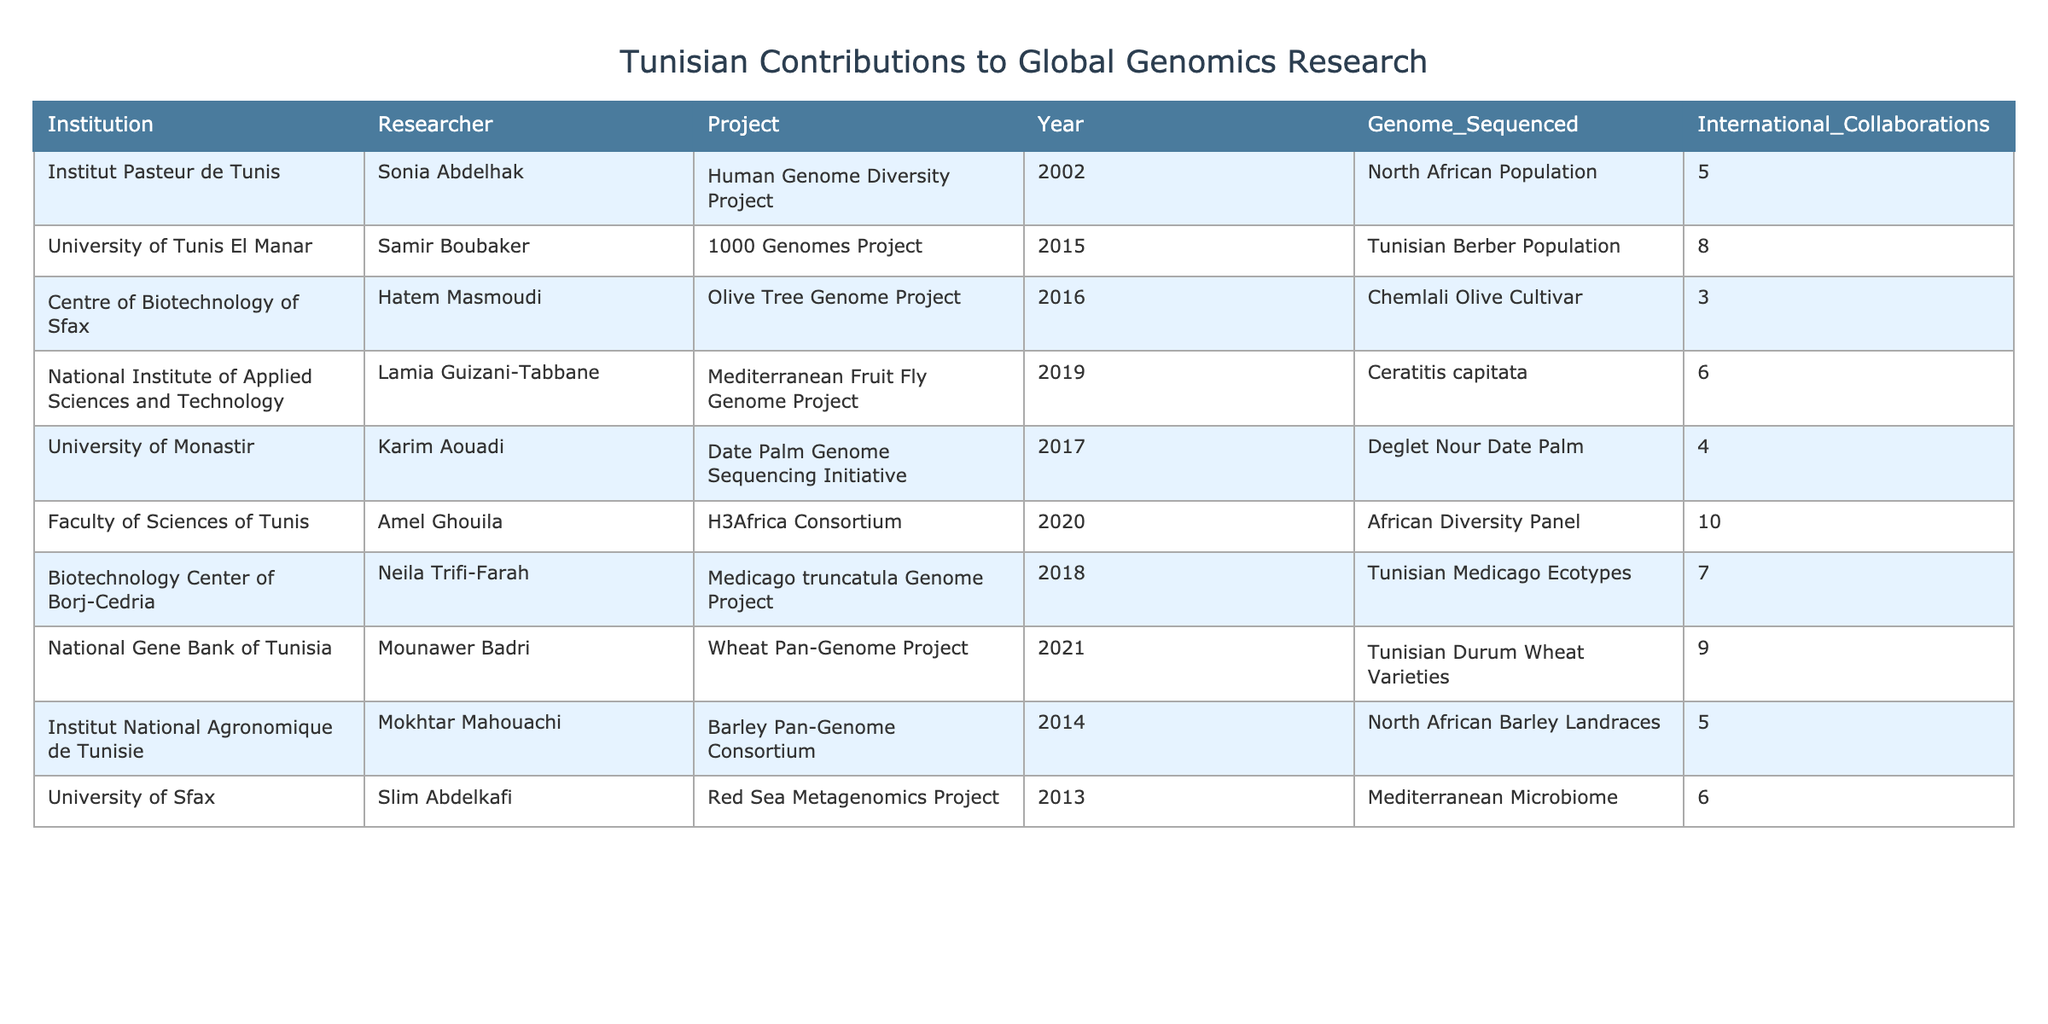What institution contributed to the H3Africa Consortium project? In the table, the project "H3Africa Consortium" is associated with "Faculty of Sciences of Tunis."
Answer: Faculty of Sciences of Tunis How many genomes were sequenced by the National Gene Bank of Tunisia? The "Wheat Pan-Genome Project" at the National Gene Bank of Tunisia sequenced "Tunisian Durum Wheat Varieties," which is indicated to have sequenced 9 genomes.
Answer: 9 Who was involved in the Olive Tree Genome Project? The table shows that Hatem Masmoudi from the Centre of Biotechnology of Sfax was involved in the Olive Tree Genome Project.
Answer: Hatem Masmoudi What was the largest number of genomes sequenced in a single project? By looking at the table, the largest number of genomes sequenced is 10, as shown in the H3Africa Consortium project.
Answer: 10 In which year was the Mediterranean Fruit Fly Genome Project conducted? The table indicates that the Mediterranean Fruit Fly Genome Project took place in 2019.
Answer: 2019 What is the total number of genomes sequenced across all projects listed? Adding the values from the "Genome Sequenced" column (5 + 8 + 3 + 6 + 4 + 10 + 7 + 9 + 5 + 6) gives a total of 63 genomes sequenced across all projects.
Answer: 63 Which researcher was involved in more than one project? By reviewing the table, it can be observed that there are no researchers listed who are involved in more than one project.
Answer: No Which institution had the highest number of international collaborations associated with its projects? By examining the table, the Faculty of Sciences of Tunis had 10 international collaborations linked to the H3Africa Consortium, which is the highest among all institutions in the table.
Answer: Faculty of Sciences of Tunis If we consider the years of research projects, which project was launched earliest? The table shows that the Human Genome Diversity Project was launched in 2002, making it the earliest project listed.
Answer: Human Genome Diversity Project Is there a project that focused on a specific crop? Yes, the Date Palm Genome Sequencing Initiative is focused specifically on "Deglet Nour Date Palm," indicating it's a crop.
Answer: Yes 